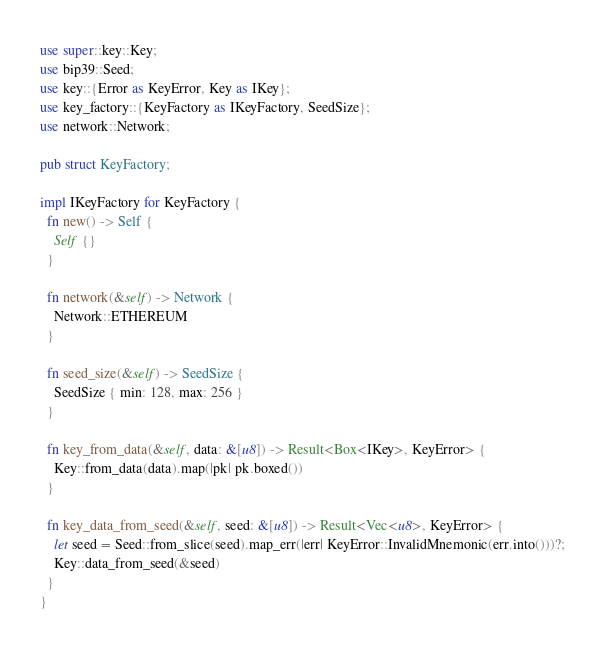Convert code to text. <code><loc_0><loc_0><loc_500><loc_500><_Rust_>use super::key::Key;
use bip39::Seed;
use key::{Error as KeyError, Key as IKey};
use key_factory::{KeyFactory as IKeyFactory, SeedSize};
use network::Network;

pub struct KeyFactory;

impl IKeyFactory for KeyFactory {
  fn new() -> Self {
    Self {}
  }

  fn network(&self) -> Network {
    Network::ETHEREUM
  }

  fn seed_size(&self) -> SeedSize {
    SeedSize { min: 128, max: 256 }
  }

  fn key_from_data(&self, data: &[u8]) -> Result<Box<IKey>, KeyError> {
    Key::from_data(data).map(|pk| pk.boxed())
  }

  fn key_data_from_seed(&self, seed: &[u8]) -> Result<Vec<u8>, KeyError> {
    let seed = Seed::from_slice(seed).map_err(|err| KeyError::InvalidMnemonic(err.into()))?;
    Key::data_from_seed(&seed)
  }
}
</code> 